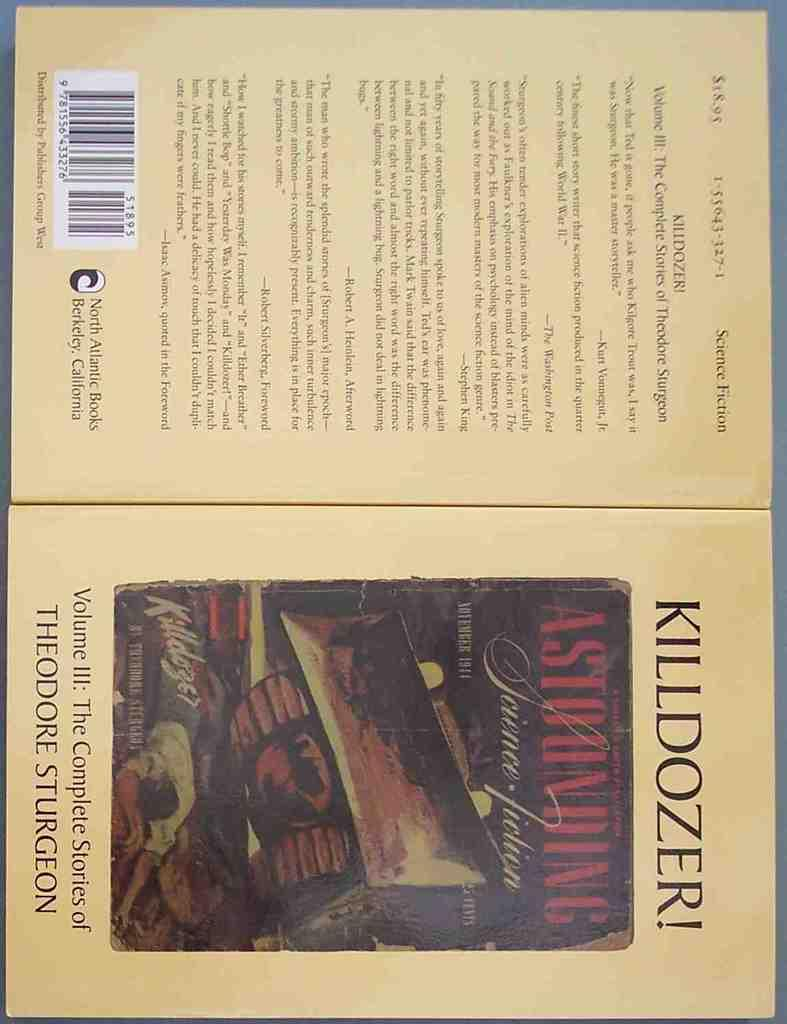Provide a one-sentence caption for the provided image. The front and back of a book by the author Theodore Sturgeon. 